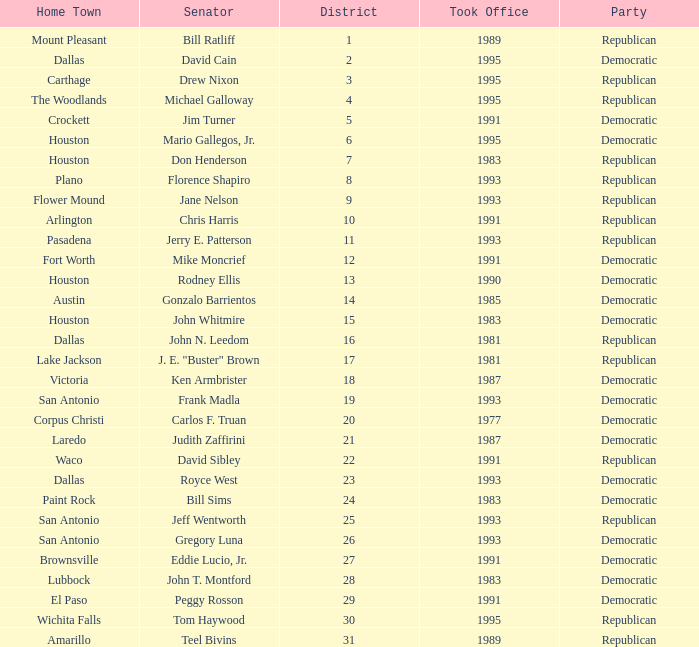What party took office after 1993 with Senator Michael Galloway? Republican. 